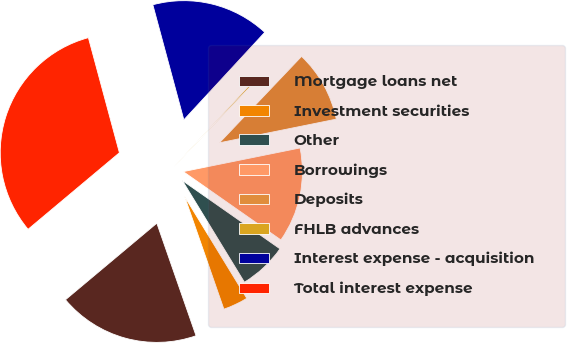<chart> <loc_0><loc_0><loc_500><loc_500><pie_chart><fcel>Mortgage loans net<fcel>Investment securities<fcel>Other<fcel>Borrowings<fcel>Deposits<fcel>FHLB advances<fcel>Interest expense - acquisition<fcel>Total interest expense<nl><fcel>19.24%<fcel>3.39%<fcel>6.56%<fcel>12.9%<fcel>9.73%<fcel>0.22%<fcel>16.07%<fcel>31.92%<nl></chart> 